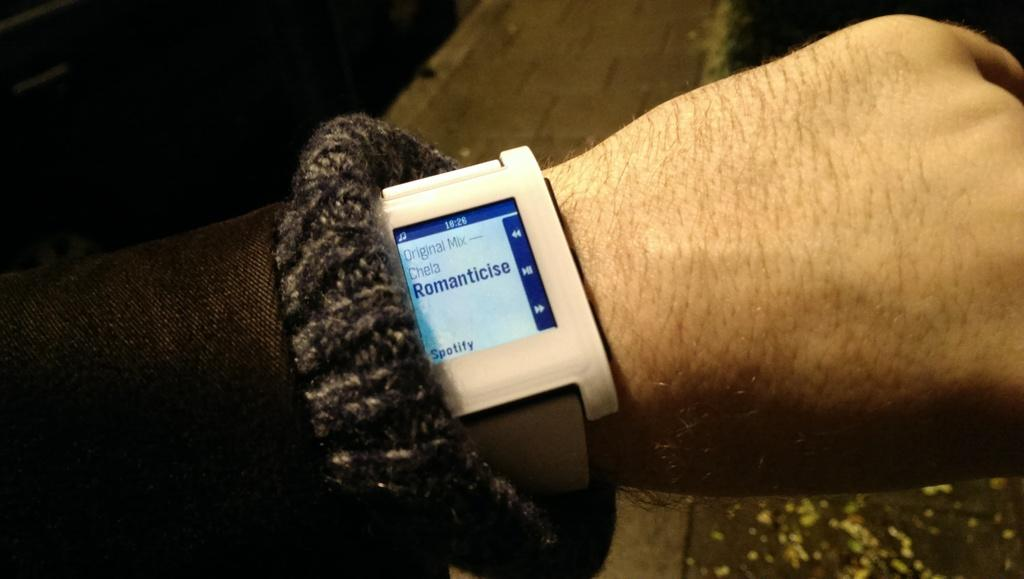<image>
Present a compact description of the photo's key features. A man's wrist has a watch playing music from Spotify. 